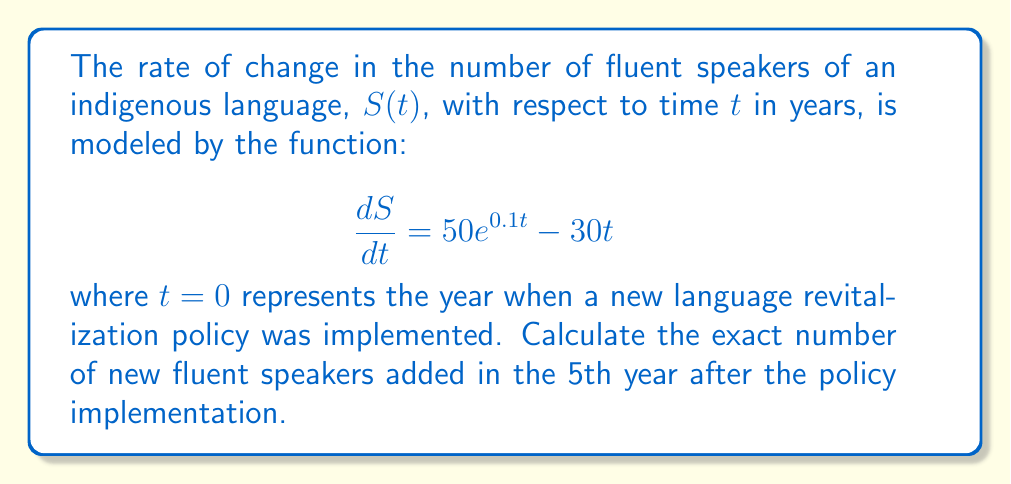Can you answer this question? To solve this problem, we need to follow these steps:

1) The given function represents the rate of change of speakers. To find the number of new speakers in the 5th year, we need to integrate this function from $t=4$ to $t=5$.

2) Set up the definite integral:
   $$\int_{4}^{5} (50e^{0.1t} - 30t) dt$$

3) Integrate the function:
   $$\left[500e^{0.1t} - 15t^2\right]_{4}^{5}$$

4) Evaluate the integral:
   $$(500e^{0.5} - 15(5)^2) - (500e^{0.4} - 15(4)^2)$$

5) Simplify:
   $$500e^{0.5} - 375 - 500e^{0.4} + 240$$
   $$= 500(e^{0.5} - e^{0.4}) - 135$$

6) Calculate the exact value:
   $$= 500(1.6487212707 - 1.4918246976) - 135$$
   $$= 500(0.1568965731) - 135$$
   $$= 78.44828655 - 135$$
   $$= -56.55171345$$

The negative result indicates a net loss of fluent speakers in the 5th year.
Answer: $-56.55171345$ speakers 